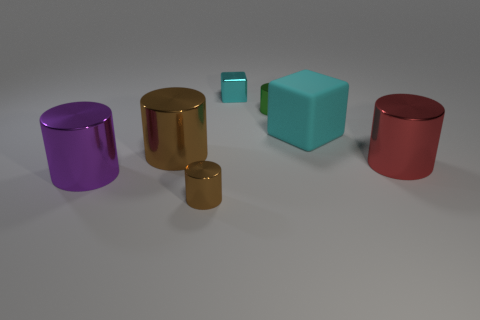Are there more small cylinders that are in front of the large cyan rubber cube than big gray rubber cylinders?
Ensure brevity in your answer.  Yes. Do the green shiny object and the brown shiny thing in front of the big purple metallic object have the same shape?
Make the answer very short. Yes. What is the shape of the big rubber thing that is the same color as the small shiny block?
Your response must be concise. Cube. How many red cylinders are in front of the cyan cube that is in front of the tiny metallic cylinder that is behind the tiny brown cylinder?
Give a very brief answer. 1. The metallic cylinder that is the same size as the green thing is what color?
Your response must be concise. Brown. There is a brown metal cylinder to the left of the object in front of the large purple thing; how big is it?
Make the answer very short. Large. There is another object that is the same color as the matte thing; what size is it?
Make the answer very short. Small. How many other things are there of the same size as the metallic cube?
Your response must be concise. 2. What number of green metal balls are there?
Give a very brief answer. 0. Is the size of the cyan matte object the same as the cyan metallic cube?
Ensure brevity in your answer.  No. 